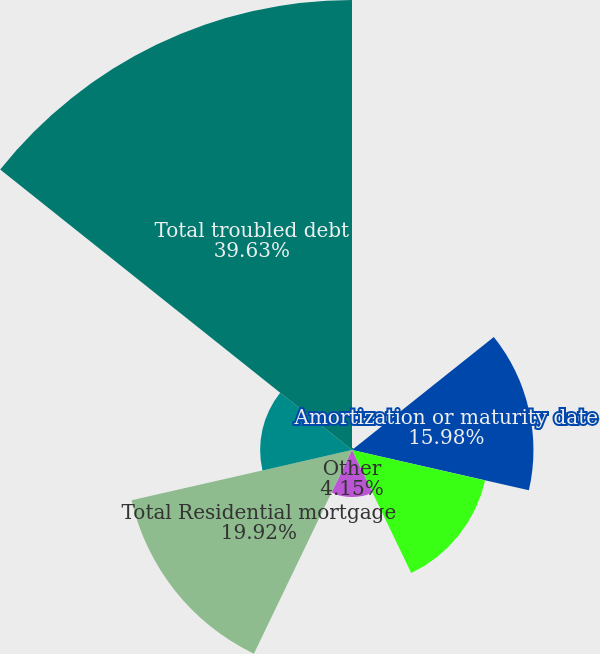<chart> <loc_0><loc_0><loc_500><loc_500><pie_chart><fcel>Interest rate reduction<fcel>Amortization or maturity date<fcel>Chapter 7 bankruptcy<fcel>Other<fcel>Total Residential mortgage<fcel>Other Total Junior-lien home<fcel>Total troubled debt<nl><fcel>0.2%<fcel>15.98%<fcel>12.03%<fcel>4.15%<fcel>19.92%<fcel>8.09%<fcel>39.64%<nl></chart> 